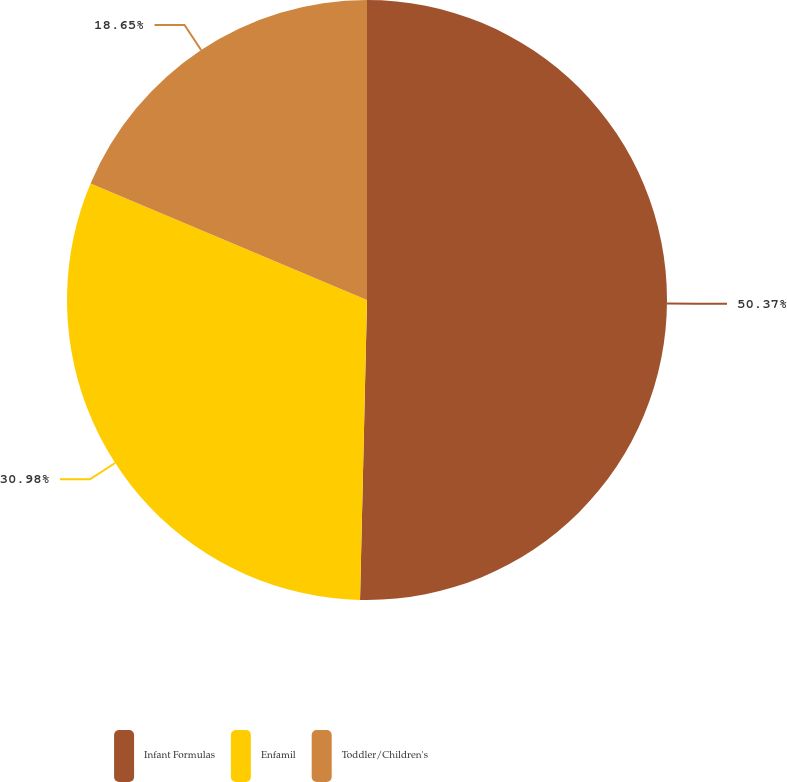Convert chart. <chart><loc_0><loc_0><loc_500><loc_500><pie_chart><fcel>Infant Formulas<fcel>Enfamil<fcel>Toddler/Children's<nl><fcel>50.37%<fcel>30.98%<fcel>18.65%<nl></chart> 